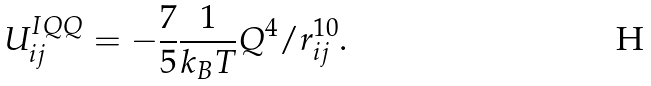Convert formula to latex. <formula><loc_0><loc_0><loc_500><loc_500>U _ { i j } ^ { I Q Q } = - \frac { 7 } { 5 } \frac { 1 } { k _ { B } T } Q ^ { 4 } / r _ { i j } ^ { 1 0 } .</formula> 